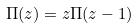<formula> <loc_0><loc_0><loc_500><loc_500>\Pi ( z ) = z \Pi ( z - 1 )</formula> 